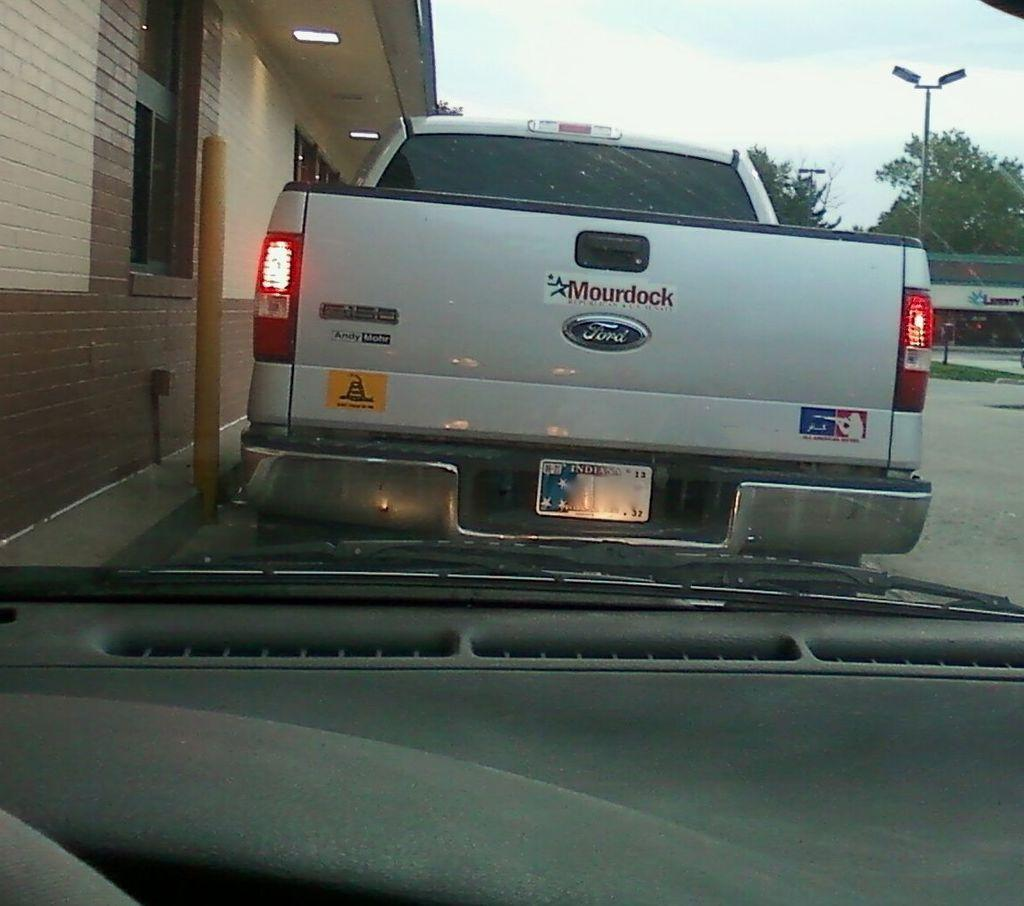<image>
Write a terse but informative summary of the picture. A ford tailgate with a big sticker that read Mourdock. 